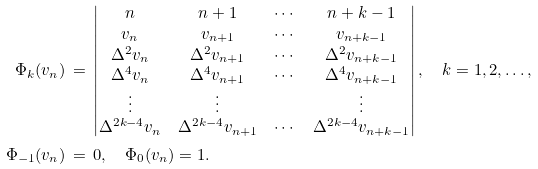<formula> <loc_0><loc_0><loc_500><loc_500>\Phi _ { k } ( v _ { n } ) & \, = \, \begin{vmatrix} n & n + 1 & \cdots & n + k - 1 \\ v _ { n } & v _ { n + 1 } & \cdots & v _ { n + k - 1 } \\ \Delta ^ { 2 } v _ { n } & \Delta ^ { 2 } v _ { n + 1 } & \cdots & \Delta ^ { 2 } v _ { n + k - 1 } \\ \Delta ^ { 4 } v _ { n } & \Delta ^ { 4 } v _ { n + 1 } & \cdots & \Delta ^ { 4 } v _ { n + k - 1 } \\ \vdots & \vdots & & \vdots \\ \Delta ^ { 2 k - 4 } v _ { n } & \Delta ^ { 2 k - 4 } v _ { n + 1 } & \cdots & \Delta ^ { 2 k - 4 } v _ { n + k - 1 } \end{vmatrix} , \quad k = 1 , 2 , \dots , \\ \Phi _ { - 1 } ( v _ { n } ) & \, = \, 0 , \quad \Phi _ { 0 } ( v _ { n } ) = 1 .</formula> 